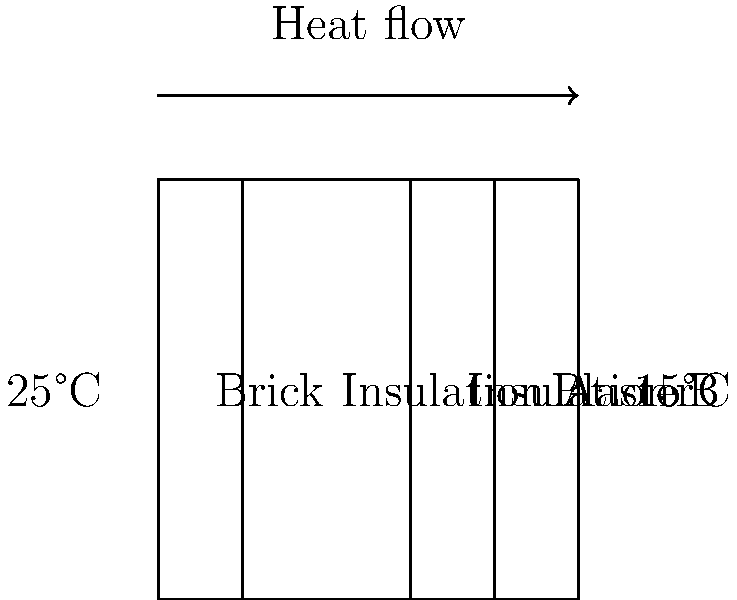As a tour guide explaining the energy efficiency of local buildings, you come across a wall with multiple layers of insulation. The wall consists of brick (20 cm), insulation A (40 cm), insulation B (20 cm), and plaster (20 cm), with indoor and outdoor temperatures of 25°C and 15°C respectively. If the thermal conductivities (in W/m·K) are: brick = 0.8, insulation A = 0.04, insulation B = 0.03, and plaster = 0.5, what is the total heat flux through the wall in W/m²? To calculate the heat flux, we'll use the concept of thermal resistance and Fourier's law of heat conduction. Here's the step-by-step process:

1. Calculate the thermal resistance (R) for each layer:
   R = thickness / (thermal conductivity)
   
   Brick: $R_1 = 0.20 / 0.8 = 0.25$ m²·K/W
   Insulation A: $R_2 = 0.40 / 0.04 = 10$ m²·K/W
   Insulation B: $R_3 = 0.20 / 0.03 = 6.67$ m²·K/W
   Plaster: $R_4 = 0.20 / 0.5 = 0.4$ m²·K/W

2. Calculate the total thermal resistance:
   $R_{total} = R_1 + R_2 + R_3 + R_4 = 0.25 + 10 + 6.67 + 0.4 = 17.32$ m²·K/W

3. Calculate the temperature difference:
   $\Delta T = T_{indoor} - T_{outdoor} = 25°C - 15°C = 10°C$

4. Apply Fourier's law of heat conduction:
   Heat flux = $q = \frac{\Delta T}{R_{total}}$

5. Substitute the values:
   $q = \frac{10°C}{17.32 \text{ m²·K/W}} = 0.577$ W/m²

Therefore, the total heat flux through the wall is approximately 0.577 W/m².
Answer: 0.577 W/m² 